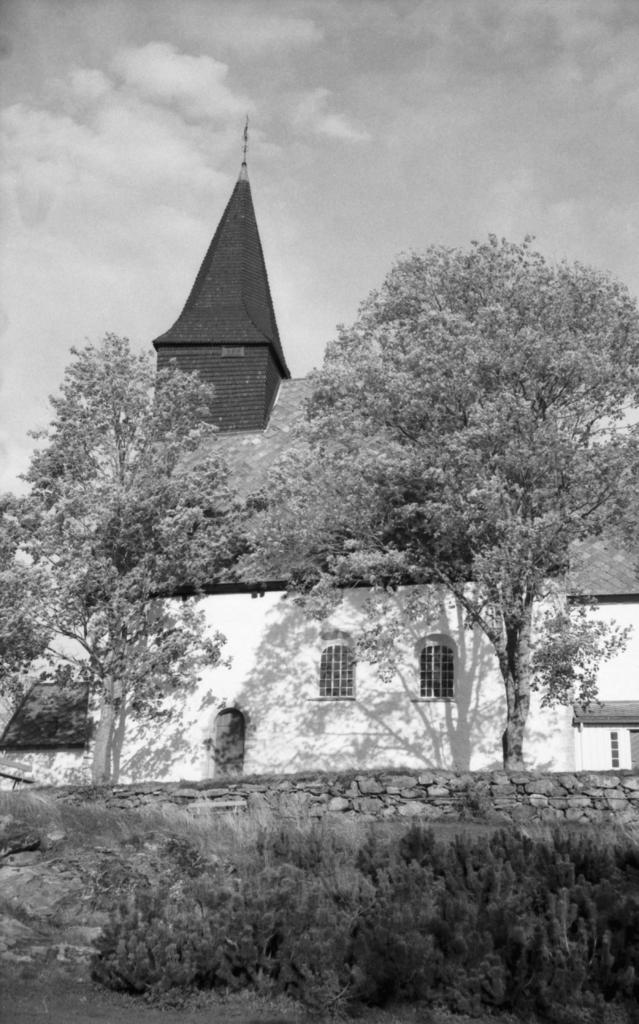What type of structure can be seen in the image? There is a building in the image. What material is used to construct the wall in the image? The wall in the image is built with cobblestones. What type of vegetation is present in the image? There are plants and trees in the image. What part of the natural environment is visible in the image? The ground, trees, and sky are visible in the image. What is the color scheme of the image? The image is black and white. What level of the building is shown in the image? The image does not show a specific level of the building; it only shows the exterior of the building. What type of place is depicted in the image? The image does not depict a specific type of place; it only shows a building, cobblestone wall, plants, trees, ground, sky, and clouds. 